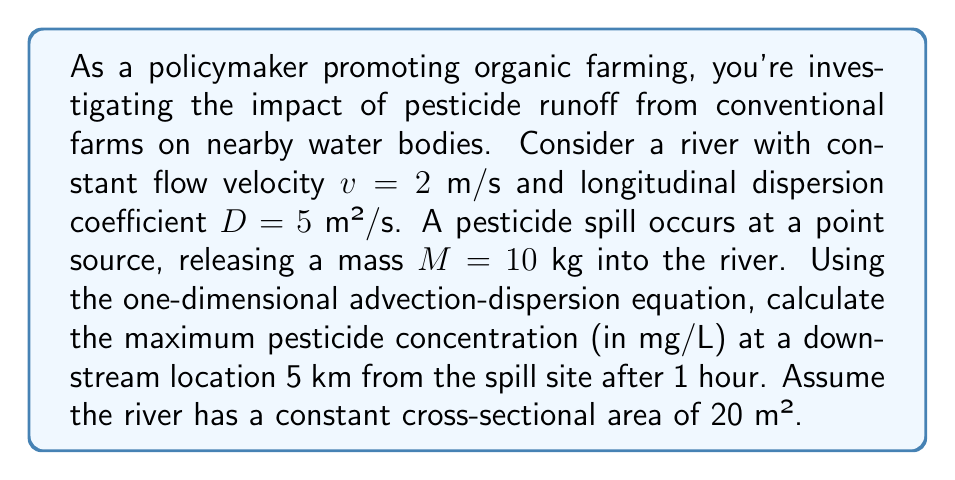Can you solve this math problem? To solve this problem, we'll use the one-dimensional advection-dispersion equation for an instantaneous point source release:

$$C(x,t) = \frac{M}{A\sqrt{4\pi Dt}} \exp\left(-\frac{(x-vt)^2}{4Dt}\right)$$

Where:
$C(x,t)$ = concentration at distance $x$ and time $t$
$M$ = mass of pesticide released
$A$ = cross-sectional area of the river
$D$ = longitudinal dispersion coefficient
$v$ = flow velocity
$x$ = distance downstream from the spill site
$t$ = time after the spill

Given:
$M = 10$ kg = 10,000,000 mg
$A = 20$ m²
$D = 5$ m²/s
$v = 2$ m/s
$x = 5000$ m
$t = 1$ hour = 3600 s

Step 1: Substitute the given values into the equation:

$$C(5000,3600) = \frac{10,000,000}{20\sqrt{4\pi \cdot 5 \cdot 3600}} \exp\left(-\frac{(5000-2\cdot3600)^2}{4\cdot5\cdot3600}\right)$$

Step 2: Simplify the expression inside the exponential function:
$$(5000-2\cdot3600)^2 = (5000-7200)^2 = (-2200)^2 = 4,840,000$$

Step 3: Calculate the concentration:

$$C(5000,3600) = \frac{10,000,000}{20\sqrt{4\pi \cdot 5 \cdot 3600}} \exp\left(-\frac{4,840,000}{4\cdot5\cdot3600}\right)$$

$$C(5000,3600) = \frac{500,000}{151.98} \exp(-67.22)$$

$$C(5000,3600) = 3289.25 \cdot 2.33 \times 10^{-30}$$

$$C(5000,3600) = 7.66 \times 10^{-27} \text{ mg/L}$$

This extremely low concentration indicates that the pesticide has dispersed significantly and is practically undetectable at the given location and time.
Answer: The maximum pesticide concentration at 5 km downstream after 1 hour is approximately $7.66 \times 10^{-27}$ mg/L. 